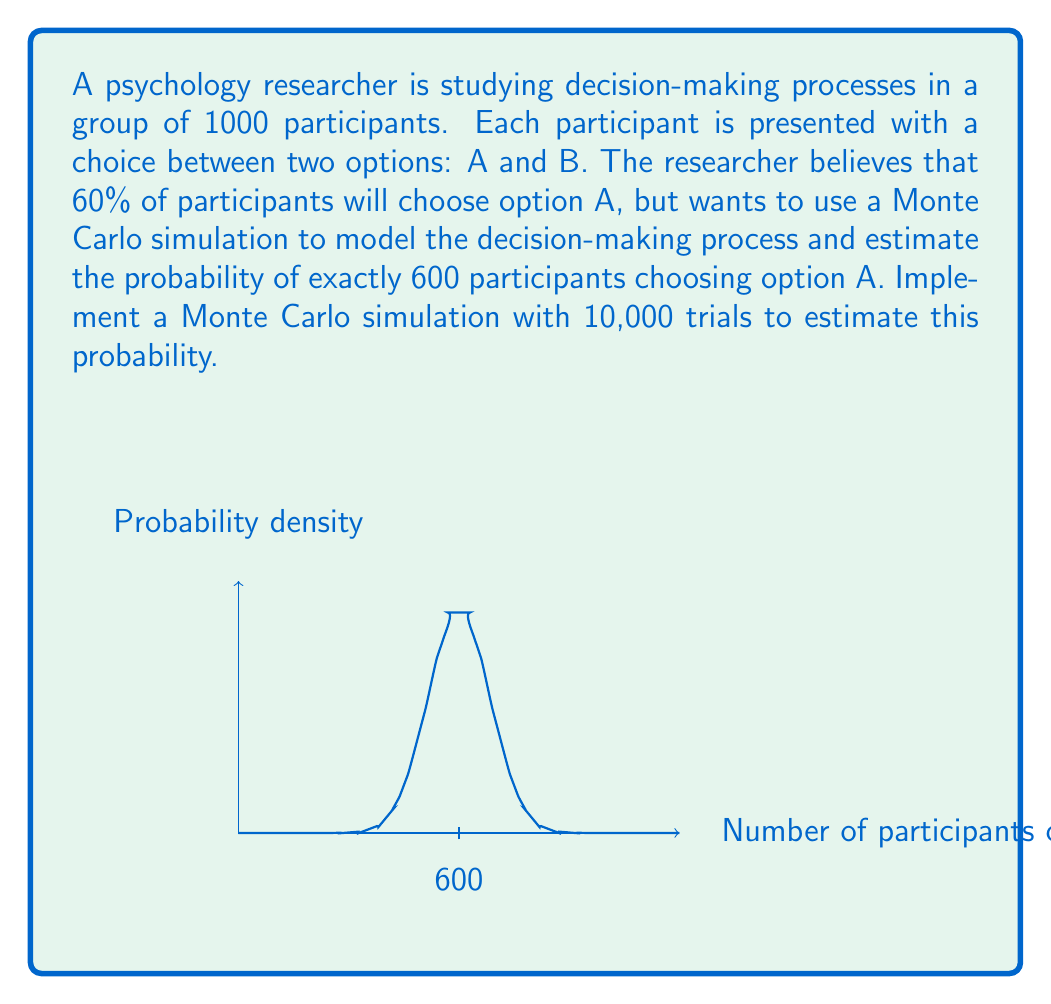What is the answer to this math problem? To solve this problem using a Monte Carlo simulation, we'll follow these steps:

1) Set up the simulation parameters:
   - Number of participants: $n = 1000$
   - Probability of choosing A: $p = 0.6$
   - Number of trials: $N = 10000$
   - Target count: $k = 600$

2) For each trial:
   a) Generate 1000 random numbers between 0 and 1
   b) Count how many of these numbers are less than or equal to 0.6 (representing choice A)
   c) Check if this count is exactly 600

3) Calculate the probability by dividing the number of successful trials by the total number of trials

Here's a Python implementation of this simulation:

```python
import numpy as np

n = 1000  # number of participants
p = 0.6   # probability of choosing A
N = 10000 # number of trials
k = 600   # target count

success = 0
for _ in range(N):
    choices = np.random.random(n) <= p
    if np.sum(choices) == k:
        success += 1

probability = success / N
```

4) The probability can be approximated theoretically using the binomial distribution:

   $$P(X = 600) = \binom{1000}{600} (0.6)^{600} (0.4)^{400} \approx 0.0283$$

5) The Monte Carlo simulation should yield a result close to this theoretical probability, with some variation due to randomness.

This simulation demonstrates how Monte Carlo methods can be used to model complex decision-making processes and estimate probabilities that might be difficult to calculate analytically, especially for large sample sizes or more complex scenarios.
Answer: Approximately 0.0283 (may vary slightly due to randomness in the simulation) 